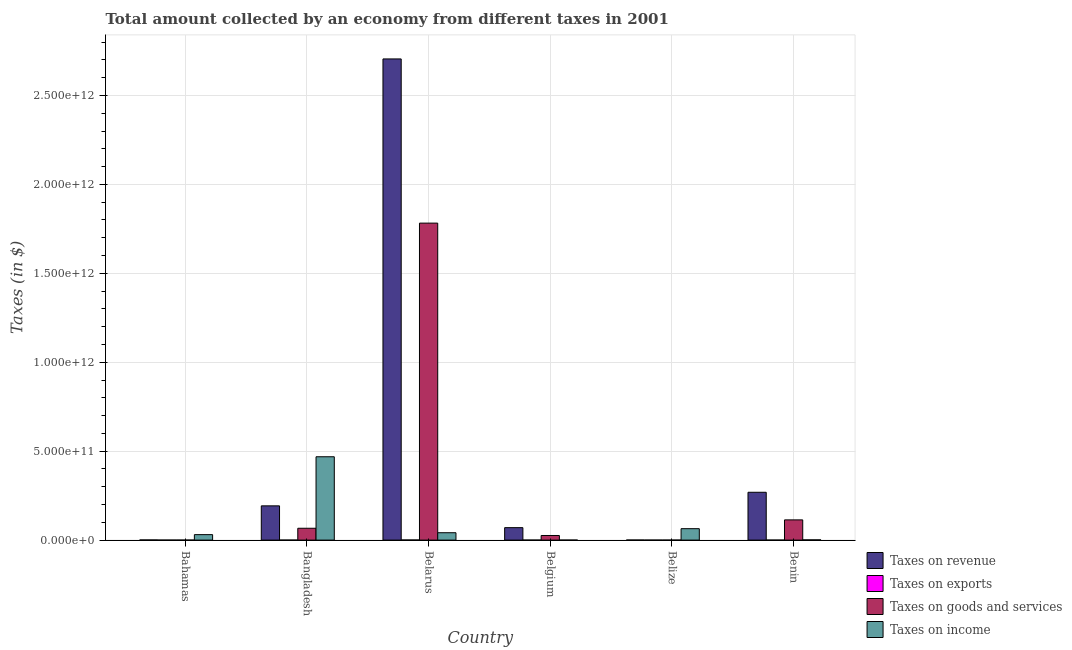How many different coloured bars are there?
Offer a very short reply. 4. Are the number of bars per tick equal to the number of legend labels?
Provide a short and direct response. Yes. What is the label of the 5th group of bars from the left?
Make the answer very short. Belize. What is the amount collected as tax on income in Belarus?
Provide a short and direct response. 4.14e+1. Across all countries, what is the maximum amount collected as tax on revenue?
Offer a terse response. 2.71e+12. Across all countries, what is the minimum amount collected as tax on revenue?
Offer a very short reply. 3.26e+08. In which country was the amount collected as tax on goods minimum?
Your response must be concise. Bahamas. What is the total amount collected as tax on income in the graph?
Ensure brevity in your answer.  6.06e+11. What is the difference between the amount collected as tax on revenue in Belgium and that in Benin?
Ensure brevity in your answer.  -1.99e+11. What is the difference between the amount collected as tax on income in Belize and the amount collected as tax on revenue in Belgium?
Provide a short and direct response. -5.74e+09. What is the average amount collected as tax on exports per country?
Give a very brief answer. 1.33e+08. What is the difference between the amount collected as tax on income and amount collected as tax on revenue in Bahamas?
Your answer should be compact. 2.99e+1. What is the ratio of the amount collected as tax on exports in Bangladesh to that in Belgium?
Your answer should be very brief. 0. What is the difference between the highest and the second highest amount collected as tax on goods?
Your answer should be very brief. 1.67e+12. What is the difference between the highest and the lowest amount collected as tax on goods?
Offer a very short reply. 1.78e+12. In how many countries, is the amount collected as tax on goods greater than the average amount collected as tax on goods taken over all countries?
Keep it short and to the point. 1. Is the sum of the amount collected as tax on income in Bahamas and Benin greater than the maximum amount collected as tax on goods across all countries?
Offer a very short reply. No. Is it the case that in every country, the sum of the amount collected as tax on revenue and amount collected as tax on exports is greater than the sum of amount collected as tax on goods and amount collected as tax on income?
Provide a short and direct response. No. What does the 2nd bar from the left in Benin represents?
Keep it short and to the point. Taxes on exports. What does the 3rd bar from the right in Bangladesh represents?
Your response must be concise. Taxes on exports. Is it the case that in every country, the sum of the amount collected as tax on revenue and amount collected as tax on exports is greater than the amount collected as tax on goods?
Give a very brief answer. Yes. Are all the bars in the graph horizontal?
Your answer should be very brief. No. How many countries are there in the graph?
Provide a succinct answer. 6. What is the difference between two consecutive major ticks on the Y-axis?
Give a very brief answer. 5.00e+11. Does the graph contain any zero values?
Your answer should be compact. No. Does the graph contain grids?
Keep it short and to the point. Yes. Where does the legend appear in the graph?
Provide a succinct answer. Bottom right. How are the legend labels stacked?
Provide a succinct answer. Vertical. What is the title of the graph?
Make the answer very short. Total amount collected by an economy from different taxes in 2001. What is the label or title of the X-axis?
Make the answer very short. Country. What is the label or title of the Y-axis?
Keep it short and to the point. Taxes (in $). What is the Taxes (in $) of Taxes on revenue in Bahamas?
Offer a very short reply. 8.20e+08. What is the Taxes (in $) of Taxes on exports in Bahamas?
Give a very brief answer. 1.32e+07. What is the Taxes (in $) of Taxes on goods and services in Bahamas?
Offer a very short reply. 5.29e+07. What is the Taxes (in $) of Taxes on income in Bahamas?
Ensure brevity in your answer.  3.07e+1. What is the Taxes (in $) of Taxes on revenue in Bangladesh?
Keep it short and to the point. 1.93e+11. What is the Taxes (in $) in Taxes on exports in Bangladesh?
Give a very brief answer. 1.46e+04. What is the Taxes (in $) of Taxes on goods and services in Bangladesh?
Offer a terse response. 6.66e+1. What is the Taxes (in $) of Taxes on income in Bangladesh?
Your answer should be compact. 4.69e+11. What is the Taxes (in $) of Taxes on revenue in Belarus?
Offer a terse response. 2.71e+12. What is the Taxes (in $) in Taxes on exports in Belarus?
Give a very brief answer. 6.54e+08. What is the Taxes (in $) of Taxes on goods and services in Belarus?
Give a very brief answer. 1.78e+12. What is the Taxes (in $) of Taxes on income in Belarus?
Your answer should be compact. 4.14e+1. What is the Taxes (in $) in Taxes on revenue in Belgium?
Provide a short and direct response. 7.00e+1. What is the Taxes (in $) of Taxes on exports in Belgium?
Your answer should be very brief. 1.03e+08. What is the Taxes (in $) of Taxes on goods and services in Belgium?
Your answer should be compact. 2.59e+1. What is the Taxes (in $) of Taxes on income in Belgium?
Make the answer very short. 7.70e+07. What is the Taxes (in $) in Taxes on revenue in Belize?
Provide a short and direct response. 3.26e+08. What is the Taxes (in $) of Taxes on exports in Belize?
Keep it short and to the point. 3.00e+07. What is the Taxes (in $) of Taxes on goods and services in Belize?
Keep it short and to the point. 1.08e+08. What is the Taxes (in $) of Taxes on income in Belize?
Offer a terse response. 6.43e+1. What is the Taxes (in $) in Taxes on revenue in Benin?
Give a very brief answer. 2.69e+11. What is the Taxes (in $) in Taxes on goods and services in Benin?
Keep it short and to the point. 1.14e+11. What is the Taxes (in $) in Taxes on income in Benin?
Ensure brevity in your answer.  1.19e+09. Across all countries, what is the maximum Taxes (in $) in Taxes on revenue?
Offer a very short reply. 2.71e+12. Across all countries, what is the maximum Taxes (in $) of Taxes on exports?
Your answer should be very brief. 6.54e+08. Across all countries, what is the maximum Taxes (in $) of Taxes on goods and services?
Provide a succinct answer. 1.78e+12. Across all countries, what is the maximum Taxes (in $) of Taxes on income?
Your answer should be compact. 4.69e+11. Across all countries, what is the minimum Taxes (in $) in Taxes on revenue?
Your answer should be very brief. 3.26e+08. Across all countries, what is the minimum Taxes (in $) of Taxes on exports?
Your answer should be compact. 1.46e+04. Across all countries, what is the minimum Taxes (in $) of Taxes on goods and services?
Offer a very short reply. 5.29e+07. Across all countries, what is the minimum Taxes (in $) in Taxes on income?
Ensure brevity in your answer.  7.70e+07. What is the total Taxes (in $) of Taxes on revenue in the graph?
Give a very brief answer. 3.24e+12. What is the total Taxes (in $) in Taxes on exports in the graph?
Keep it short and to the point. 8.01e+08. What is the total Taxes (in $) of Taxes on goods and services in the graph?
Ensure brevity in your answer.  1.99e+12. What is the total Taxes (in $) of Taxes on income in the graph?
Your answer should be compact. 6.06e+11. What is the difference between the Taxes (in $) in Taxes on revenue in Bahamas and that in Bangladesh?
Offer a terse response. -1.92e+11. What is the difference between the Taxes (in $) of Taxes on exports in Bahamas and that in Bangladesh?
Your response must be concise. 1.32e+07. What is the difference between the Taxes (in $) of Taxes on goods and services in Bahamas and that in Bangladesh?
Provide a succinct answer. -6.65e+1. What is the difference between the Taxes (in $) of Taxes on income in Bahamas and that in Bangladesh?
Keep it short and to the point. -4.38e+11. What is the difference between the Taxes (in $) of Taxes on revenue in Bahamas and that in Belarus?
Your answer should be very brief. -2.70e+12. What is the difference between the Taxes (in $) of Taxes on exports in Bahamas and that in Belarus?
Make the answer very short. -6.40e+08. What is the difference between the Taxes (in $) in Taxes on goods and services in Bahamas and that in Belarus?
Provide a succinct answer. -1.78e+12. What is the difference between the Taxes (in $) of Taxes on income in Bahamas and that in Belarus?
Your answer should be compact. -1.07e+1. What is the difference between the Taxes (in $) in Taxes on revenue in Bahamas and that in Belgium?
Make the answer very short. -6.92e+1. What is the difference between the Taxes (in $) in Taxes on exports in Bahamas and that in Belgium?
Make the answer very short. -8.98e+07. What is the difference between the Taxes (in $) in Taxes on goods and services in Bahamas and that in Belgium?
Give a very brief answer. -2.59e+1. What is the difference between the Taxes (in $) in Taxes on income in Bahamas and that in Belgium?
Provide a short and direct response. 3.07e+1. What is the difference between the Taxes (in $) in Taxes on revenue in Bahamas and that in Belize?
Offer a very short reply. 4.94e+08. What is the difference between the Taxes (in $) of Taxes on exports in Bahamas and that in Belize?
Give a very brief answer. -1.68e+07. What is the difference between the Taxes (in $) in Taxes on goods and services in Bahamas and that in Belize?
Provide a succinct answer. -5.50e+07. What is the difference between the Taxes (in $) of Taxes on income in Bahamas and that in Belize?
Provide a short and direct response. -3.35e+1. What is the difference between the Taxes (in $) in Taxes on revenue in Bahamas and that in Benin?
Ensure brevity in your answer.  -2.68e+11. What is the difference between the Taxes (in $) of Taxes on exports in Bahamas and that in Benin?
Provide a short and direct response. 1.23e+07. What is the difference between the Taxes (in $) in Taxes on goods and services in Bahamas and that in Benin?
Offer a very short reply. -1.14e+11. What is the difference between the Taxes (in $) of Taxes on income in Bahamas and that in Benin?
Ensure brevity in your answer.  2.96e+1. What is the difference between the Taxes (in $) of Taxes on revenue in Bangladesh and that in Belarus?
Your answer should be very brief. -2.51e+12. What is the difference between the Taxes (in $) of Taxes on exports in Bangladesh and that in Belarus?
Your answer should be compact. -6.54e+08. What is the difference between the Taxes (in $) in Taxes on goods and services in Bangladesh and that in Belarus?
Your answer should be very brief. -1.72e+12. What is the difference between the Taxes (in $) in Taxes on income in Bangladesh and that in Belarus?
Offer a very short reply. 4.27e+11. What is the difference between the Taxes (in $) in Taxes on revenue in Bangladesh and that in Belgium?
Keep it short and to the point. 1.23e+11. What is the difference between the Taxes (in $) of Taxes on exports in Bangladesh and that in Belgium?
Offer a very short reply. -1.03e+08. What is the difference between the Taxes (in $) in Taxes on goods and services in Bangladesh and that in Belgium?
Your response must be concise. 4.06e+1. What is the difference between the Taxes (in $) in Taxes on income in Bangladesh and that in Belgium?
Give a very brief answer. 4.69e+11. What is the difference between the Taxes (in $) of Taxes on revenue in Bangladesh and that in Belize?
Make the answer very short. 1.92e+11. What is the difference between the Taxes (in $) of Taxes on exports in Bangladesh and that in Belize?
Your answer should be compact. -3.00e+07. What is the difference between the Taxes (in $) of Taxes on goods and services in Bangladesh and that in Belize?
Offer a terse response. 6.65e+1. What is the difference between the Taxes (in $) in Taxes on income in Bangladesh and that in Belize?
Make the answer very short. 4.04e+11. What is the difference between the Taxes (in $) in Taxes on revenue in Bangladesh and that in Benin?
Your answer should be very brief. -7.63e+1. What is the difference between the Taxes (in $) of Taxes on exports in Bangladesh and that in Benin?
Keep it short and to the point. -8.85e+05. What is the difference between the Taxes (in $) of Taxes on goods and services in Bangladesh and that in Benin?
Offer a very short reply. -4.72e+1. What is the difference between the Taxes (in $) of Taxes on income in Bangladesh and that in Benin?
Keep it short and to the point. 4.67e+11. What is the difference between the Taxes (in $) of Taxes on revenue in Belarus and that in Belgium?
Provide a short and direct response. 2.64e+12. What is the difference between the Taxes (in $) in Taxes on exports in Belarus and that in Belgium?
Your answer should be compact. 5.51e+08. What is the difference between the Taxes (in $) in Taxes on goods and services in Belarus and that in Belgium?
Make the answer very short. 1.76e+12. What is the difference between the Taxes (in $) in Taxes on income in Belarus and that in Belgium?
Provide a succinct answer. 4.14e+1. What is the difference between the Taxes (in $) of Taxes on revenue in Belarus and that in Belize?
Offer a very short reply. 2.71e+12. What is the difference between the Taxes (in $) in Taxes on exports in Belarus and that in Belize?
Your answer should be compact. 6.24e+08. What is the difference between the Taxes (in $) in Taxes on goods and services in Belarus and that in Belize?
Your answer should be compact. 1.78e+12. What is the difference between the Taxes (in $) of Taxes on income in Belarus and that in Belize?
Offer a very short reply. -2.28e+1. What is the difference between the Taxes (in $) of Taxes on revenue in Belarus and that in Benin?
Provide a short and direct response. 2.44e+12. What is the difference between the Taxes (in $) of Taxes on exports in Belarus and that in Benin?
Your answer should be very brief. 6.53e+08. What is the difference between the Taxes (in $) in Taxes on goods and services in Belarus and that in Benin?
Provide a succinct answer. 1.67e+12. What is the difference between the Taxes (in $) of Taxes on income in Belarus and that in Benin?
Your response must be concise. 4.02e+1. What is the difference between the Taxes (in $) of Taxes on revenue in Belgium and that in Belize?
Make the answer very short. 6.97e+1. What is the difference between the Taxes (in $) in Taxes on exports in Belgium and that in Belize?
Offer a terse response. 7.30e+07. What is the difference between the Taxes (in $) of Taxes on goods and services in Belgium and that in Belize?
Offer a very short reply. 2.58e+1. What is the difference between the Taxes (in $) of Taxes on income in Belgium and that in Belize?
Provide a short and direct response. -6.42e+1. What is the difference between the Taxes (in $) of Taxes on revenue in Belgium and that in Benin?
Make the answer very short. -1.99e+11. What is the difference between the Taxes (in $) of Taxes on exports in Belgium and that in Benin?
Provide a short and direct response. 1.02e+08. What is the difference between the Taxes (in $) of Taxes on goods and services in Belgium and that in Benin?
Your answer should be very brief. -8.78e+1. What is the difference between the Taxes (in $) of Taxes on income in Belgium and that in Benin?
Ensure brevity in your answer.  -1.11e+09. What is the difference between the Taxes (in $) in Taxes on revenue in Belize and that in Benin?
Offer a terse response. -2.69e+11. What is the difference between the Taxes (in $) in Taxes on exports in Belize and that in Benin?
Your answer should be very brief. 2.91e+07. What is the difference between the Taxes (in $) of Taxes on goods and services in Belize and that in Benin?
Ensure brevity in your answer.  -1.14e+11. What is the difference between the Taxes (in $) of Taxes on income in Belize and that in Benin?
Provide a succinct answer. 6.31e+1. What is the difference between the Taxes (in $) in Taxes on revenue in Bahamas and the Taxes (in $) in Taxes on exports in Bangladesh?
Offer a very short reply. 8.20e+08. What is the difference between the Taxes (in $) of Taxes on revenue in Bahamas and the Taxes (in $) of Taxes on goods and services in Bangladesh?
Give a very brief answer. -6.57e+1. What is the difference between the Taxes (in $) in Taxes on revenue in Bahamas and the Taxes (in $) in Taxes on income in Bangladesh?
Provide a succinct answer. -4.68e+11. What is the difference between the Taxes (in $) in Taxes on exports in Bahamas and the Taxes (in $) in Taxes on goods and services in Bangladesh?
Your answer should be compact. -6.66e+1. What is the difference between the Taxes (in $) in Taxes on exports in Bahamas and the Taxes (in $) in Taxes on income in Bangladesh?
Offer a very short reply. -4.69e+11. What is the difference between the Taxes (in $) of Taxes on goods and services in Bahamas and the Taxes (in $) of Taxes on income in Bangladesh?
Provide a short and direct response. -4.69e+11. What is the difference between the Taxes (in $) in Taxes on revenue in Bahamas and the Taxes (in $) in Taxes on exports in Belarus?
Provide a succinct answer. 1.67e+08. What is the difference between the Taxes (in $) of Taxes on revenue in Bahamas and the Taxes (in $) of Taxes on goods and services in Belarus?
Provide a short and direct response. -1.78e+12. What is the difference between the Taxes (in $) in Taxes on revenue in Bahamas and the Taxes (in $) in Taxes on income in Belarus?
Your answer should be compact. -4.06e+1. What is the difference between the Taxes (in $) in Taxes on exports in Bahamas and the Taxes (in $) in Taxes on goods and services in Belarus?
Make the answer very short. -1.78e+12. What is the difference between the Taxes (in $) of Taxes on exports in Bahamas and the Taxes (in $) of Taxes on income in Belarus?
Provide a short and direct response. -4.14e+1. What is the difference between the Taxes (in $) in Taxes on goods and services in Bahamas and the Taxes (in $) in Taxes on income in Belarus?
Provide a succinct answer. -4.14e+1. What is the difference between the Taxes (in $) in Taxes on revenue in Bahamas and the Taxes (in $) in Taxes on exports in Belgium?
Ensure brevity in your answer.  7.17e+08. What is the difference between the Taxes (in $) of Taxes on revenue in Bahamas and the Taxes (in $) of Taxes on goods and services in Belgium?
Offer a terse response. -2.51e+1. What is the difference between the Taxes (in $) of Taxes on revenue in Bahamas and the Taxes (in $) of Taxes on income in Belgium?
Keep it short and to the point. 7.43e+08. What is the difference between the Taxes (in $) in Taxes on exports in Bahamas and the Taxes (in $) in Taxes on goods and services in Belgium?
Keep it short and to the point. -2.59e+1. What is the difference between the Taxes (in $) in Taxes on exports in Bahamas and the Taxes (in $) in Taxes on income in Belgium?
Give a very brief answer. -6.38e+07. What is the difference between the Taxes (in $) of Taxes on goods and services in Bahamas and the Taxes (in $) of Taxes on income in Belgium?
Ensure brevity in your answer.  -2.41e+07. What is the difference between the Taxes (in $) of Taxes on revenue in Bahamas and the Taxes (in $) of Taxes on exports in Belize?
Give a very brief answer. 7.90e+08. What is the difference between the Taxes (in $) of Taxes on revenue in Bahamas and the Taxes (in $) of Taxes on goods and services in Belize?
Your answer should be very brief. 7.12e+08. What is the difference between the Taxes (in $) of Taxes on revenue in Bahamas and the Taxes (in $) of Taxes on income in Belize?
Your answer should be compact. -6.34e+1. What is the difference between the Taxes (in $) in Taxes on exports in Bahamas and the Taxes (in $) in Taxes on goods and services in Belize?
Ensure brevity in your answer.  -9.47e+07. What is the difference between the Taxes (in $) of Taxes on exports in Bahamas and the Taxes (in $) of Taxes on income in Belize?
Provide a short and direct response. -6.42e+1. What is the difference between the Taxes (in $) in Taxes on goods and services in Bahamas and the Taxes (in $) in Taxes on income in Belize?
Your response must be concise. -6.42e+1. What is the difference between the Taxes (in $) in Taxes on revenue in Bahamas and the Taxes (in $) in Taxes on exports in Benin?
Your response must be concise. 8.19e+08. What is the difference between the Taxes (in $) of Taxes on revenue in Bahamas and the Taxes (in $) of Taxes on goods and services in Benin?
Ensure brevity in your answer.  -1.13e+11. What is the difference between the Taxes (in $) of Taxes on revenue in Bahamas and the Taxes (in $) of Taxes on income in Benin?
Provide a short and direct response. -3.72e+08. What is the difference between the Taxes (in $) of Taxes on exports in Bahamas and the Taxes (in $) of Taxes on goods and services in Benin?
Your answer should be compact. -1.14e+11. What is the difference between the Taxes (in $) in Taxes on exports in Bahamas and the Taxes (in $) in Taxes on income in Benin?
Ensure brevity in your answer.  -1.18e+09. What is the difference between the Taxes (in $) of Taxes on goods and services in Bahamas and the Taxes (in $) of Taxes on income in Benin?
Your answer should be very brief. -1.14e+09. What is the difference between the Taxes (in $) of Taxes on revenue in Bangladesh and the Taxes (in $) of Taxes on exports in Belarus?
Ensure brevity in your answer.  1.92e+11. What is the difference between the Taxes (in $) of Taxes on revenue in Bangladesh and the Taxes (in $) of Taxes on goods and services in Belarus?
Provide a short and direct response. -1.59e+12. What is the difference between the Taxes (in $) of Taxes on revenue in Bangladesh and the Taxes (in $) of Taxes on income in Belarus?
Ensure brevity in your answer.  1.51e+11. What is the difference between the Taxes (in $) in Taxes on exports in Bangladesh and the Taxes (in $) in Taxes on goods and services in Belarus?
Keep it short and to the point. -1.78e+12. What is the difference between the Taxes (in $) in Taxes on exports in Bangladesh and the Taxes (in $) in Taxes on income in Belarus?
Keep it short and to the point. -4.14e+1. What is the difference between the Taxes (in $) of Taxes on goods and services in Bangladesh and the Taxes (in $) of Taxes on income in Belarus?
Your answer should be very brief. 2.51e+1. What is the difference between the Taxes (in $) in Taxes on revenue in Bangladesh and the Taxes (in $) in Taxes on exports in Belgium?
Offer a very short reply. 1.93e+11. What is the difference between the Taxes (in $) in Taxes on revenue in Bangladesh and the Taxes (in $) in Taxes on goods and services in Belgium?
Offer a terse response. 1.67e+11. What is the difference between the Taxes (in $) in Taxes on revenue in Bangladesh and the Taxes (in $) in Taxes on income in Belgium?
Your answer should be very brief. 1.93e+11. What is the difference between the Taxes (in $) in Taxes on exports in Bangladesh and the Taxes (in $) in Taxes on goods and services in Belgium?
Offer a terse response. -2.59e+1. What is the difference between the Taxes (in $) in Taxes on exports in Bangladesh and the Taxes (in $) in Taxes on income in Belgium?
Your response must be concise. -7.70e+07. What is the difference between the Taxes (in $) of Taxes on goods and services in Bangladesh and the Taxes (in $) of Taxes on income in Belgium?
Your response must be concise. 6.65e+1. What is the difference between the Taxes (in $) of Taxes on revenue in Bangladesh and the Taxes (in $) of Taxes on exports in Belize?
Your answer should be very brief. 1.93e+11. What is the difference between the Taxes (in $) in Taxes on revenue in Bangladesh and the Taxes (in $) in Taxes on goods and services in Belize?
Your answer should be very brief. 1.92e+11. What is the difference between the Taxes (in $) of Taxes on revenue in Bangladesh and the Taxes (in $) of Taxes on income in Belize?
Your answer should be very brief. 1.28e+11. What is the difference between the Taxes (in $) in Taxes on exports in Bangladesh and the Taxes (in $) in Taxes on goods and services in Belize?
Your answer should be very brief. -1.08e+08. What is the difference between the Taxes (in $) in Taxes on exports in Bangladesh and the Taxes (in $) in Taxes on income in Belize?
Your response must be concise. -6.43e+1. What is the difference between the Taxes (in $) of Taxes on goods and services in Bangladesh and the Taxes (in $) of Taxes on income in Belize?
Keep it short and to the point. 2.31e+09. What is the difference between the Taxes (in $) in Taxes on revenue in Bangladesh and the Taxes (in $) in Taxes on exports in Benin?
Offer a very short reply. 1.93e+11. What is the difference between the Taxes (in $) in Taxes on revenue in Bangladesh and the Taxes (in $) in Taxes on goods and services in Benin?
Provide a short and direct response. 7.89e+1. What is the difference between the Taxes (in $) of Taxes on revenue in Bangladesh and the Taxes (in $) of Taxes on income in Benin?
Offer a terse response. 1.91e+11. What is the difference between the Taxes (in $) in Taxes on exports in Bangladesh and the Taxes (in $) in Taxes on goods and services in Benin?
Make the answer very short. -1.14e+11. What is the difference between the Taxes (in $) of Taxes on exports in Bangladesh and the Taxes (in $) of Taxes on income in Benin?
Offer a very short reply. -1.19e+09. What is the difference between the Taxes (in $) of Taxes on goods and services in Bangladesh and the Taxes (in $) of Taxes on income in Benin?
Your answer should be compact. 6.54e+1. What is the difference between the Taxes (in $) of Taxes on revenue in Belarus and the Taxes (in $) of Taxes on exports in Belgium?
Offer a very short reply. 2.71e+12. What is the difference between the Taxes (in $) of Taxes on revenue in Belarus and the Taxes (in $) of Taxes on goods and services in Belgium?
Make the answer very short. 2.68e+12. What is the difference between the Taxes (in $) of Taxes on revenue in Belarus and the Taxes (in $) of Taxes on income in Belgium?
Provide a short and direct response. 2.71e+12. What is the difference between the Taxes (in $) of Taxes on exports in Belarus and the Taxes (in $) of Taxes on goods and services in Belgium?
Offer a very short reply. -2.53e+1. What is the difference between the Taxes (in $) of Taxes on exports in Belarus and the Taxes (in $) of Taxes on income in Belgium?
Give a very brief answer. 5.77e+08. What is the difference between the Taxes (in $) in Taxes on goods and services in Belarus and the Taxes (in $) in Taxes on income in Belgium?
Give a very brief answer. 1.78e+12. What is the difference between the Taxes (in $) in Taxes on revenue in Belarus and the Taxes (in $) in Taxes on exports in Belize?
Make the answer very short. 2.71e+12. What is the difference between the Taxes (in $) of Taxes on revenue in Belarus and the Taxes (in $) of Taxes on goods and services in Belize?
Your response must be concise. 2.71e+12. What is the difference between the Taxes (in $) of Taxes on revenue in Belarus and the Taxes (in $) of Taxes on income in Belize?
Give a very brief answer. 2.64e+12. What is the difference between the Taxes (in $) in Taxes on exports in Belarus and the Taxes (in $) in Taxes on goods and services in Belize?
Provide a short and direct response. 5.46e+08. What is the difference between the Taxes (in $) of Taxes on exports in Belarus and the Taxes (in $) of Taxes on income in Belize?
Give a very brief answer. -6.36e+1. What is the difference between the Taxes (in $) of Taxes on goods and services in Belarus and the Taxes (in $) of Taxes on income in Belize?
Your answer should be compact. 1.72e+12. What is the difference between the Taxes (in $) of Taxes on revenue in Belarus and the Taxes (in $) of Taxes on exports in Benin?
Offer a very short reply. 2.71e+12. What is the difference between the Taxes (in $) of Taxes on revenue in Belarus and the Taxes (in $) of Taxes on goods and services in Benin?
Ensure brevity in your answer.  2.59e+12. What is the difference between the Taxes (in $) of Taxes on revenue in Belarus and the Taxes (in $) of Taxes on income in Benin?
Ensure brevity in your answer.  2.70e+12. What is the difference between the Taxes (in $) of Taxes on exports in Belarus and the Taxes (in $) of Taxes on goods and services in Benin?
Provide a short and direct response. -1.13e+11. What is the difference between the Taxes (in $) in Taxes on exports in Belarus and the Taxes (in $) in Taxes on income in Benin?
Make the answer very short. -5.38e+08. What is the difference between the Taxes (in $) in Taxes on goods and services in Belarus and the Taxes (in $) in Taxes on income in Benin?
Give a very brief answer. 1.78e+12. What is the difference between the Taxes (in $) in Taxes on revenue in Belgium and the Taxes (in $) in Taxes on exports in Belize?
Your response must be concise. 7.00e+1. What is the difference between the Taxes (in $) of Taxes on revenue in Belgium and the Taxes (in $) of Taxes on goods and services in Belize?
Keep it short and to the point. 6.99e+1. What is the difference between the Taxes (in $) in Taxes on revenue in Belgium and the Taxes (in $) in Taxes on income in Belize?
Make the answer very short. 5.74e+09. What is the difference between the Taxes (in $) in Taxes on exports in Belgium and the Taxes (in $) in Taxes on goods and services in Belize?
Your answer should be very brief. -4.95e+06. What is the difference between the Taxes (in $) of Taxes on exports in Belgium and the Taxes (in $) of Taxes on income in Belize?
Your answer should be very brief. -6.42e+1. What is the difference between the Taxes (in $) of Taxes on goods and services in Belgium and the Taxes (in $) of Taxes on income in Belize?
Offer a terse response. -3.83e+1. What is the difference between the Taxes (in $) in Taxes on revenue in Belgium and the Taxes (in $) in Taxes on exports in Benin?
Offer a very short reply. 7.00e+1. What is the difference between the Taxes (in $) of Taxes on revenue in Belgium and the Taxes (in $) of Taxes on goods and services in Benin?
Provide a short and direct response. -4.37e+1. What is the difference between the Taxes (in $) of Taxes on revenue in Belgium and the Taxes (in $) of Taxes on income in Benin?
Your answer should be very brief. 6.88e+1. What is the difference between the Taxes (in $) in Taxes on exports in Belgium and the Taxes (in $) in Taxes on goods and services in Benin?
Provide a short and direct response. -1.14e+11. What is the difference between the Taxes (in $) in Taxes on exports in Belgium and the Taxes (in $) in Taxes on income in Benin?
Offer a very short reply. -1.09e+09. What is the difference between the Taxes (in $) in Taxes on goods and services in Belgium and the Taxes (in $) in Taxes on income in Benin?
Make the answer very short. 2.47e+1. What is the difference between the Taxes (in $) of Taxes on revenue in Belize and the Taxes (in $) of Taxes on exports in Benin?
Provide a succinct answer. 3.25e+08. What is the difference between the Taxes (in $) in Taxes on revenue in Belize and the Taxes (in $) in Taxes on goods and services in Benin?
Make the answer very short. -1.13e+11. What is the difference between the Taxes (in $) of Taxes on revenue in Belize and the Taxes (in $) of Taxes on income in Benin?
Provide a short and direct response. -8.66e+08. What is the difference between the Taxes (in $) of Taxes on exports in Belize and the Taxes (in $) of Taxes on goods and services in Benin?
Your answer should be compact. -1.14e+11. What is the difference between the Taxes (in $) of Taxes on exports in Belize and the Taxes (in $) of Taxes on income in Benin?
Make the answer very short. -1.16e+09. What is the difference between the Taxes (in $) of Taxes on goods and services in Belize and the Taxes (in $) of Taxes on income in Benin?
Provide a succinct answer. -1.08e+09. What is the average Taxes (in $) in Taxes on revenue per country?
Provide a short and direct response. 5.40e+11. What is the average Taxes (in $) of Taxes on exports per country?
Give a very brief answer. 1.33e+08. What is the average Taxes (in $) of Taxes on goods and services per country?
Offer a terse response. 3.31e+11. What is the average Taxes (in $) of Taxes on income per country?
Offer a terse response. 1.01e+11. What is the difference between the Taxes (in $) of Taxes on revenue and Taxes (in $) of Taxes on exports in Bahamas?
Your response must be concise. 8.07e+08. What is the difference between the Taxes (in $) in Taxes on revenue and Taxes (in $) in Taxes on goods and services in Bahamas?
Your answer should be compact. 7.67e+08. What is the difference between the Taxes (in $) in Taxes on revenue and Taxes (in $) in Taxes on income in Bahamas?
Keep it short and to the point. -2.99e+1. What is the difference between the Taxes (in $) of Taxes on exports and Taxes (in $) of Taxes on goods and services in Bahamas?
Provide a short and direct response. -3.97e+07. What is the difference between the Taxes (in $) of Taxes on exports and Taxes (in $) of Taxes on income in Bahamas?
Your response must be concise. -3.07e+1. What is the difference between the Taxes (in $) of Taxes on goods and services and Taxes (in $) of Taxes on income in Bahamas?
Keep it short and to the point. -3.07e+1. What is the difference between the Taxes (in $) in Taxes on revenue and Taxes (in $) in Taxes on exports in Bangladesh?
Give a very brief answer. 1.93e+11. What is the difference between the Taxes (in $) in Taxes on revenue and Taxes (in $) in Taxes on goods and services in Bangladesh?
Ensure brevity in your answer.  1.26e+11. What is the difference between the Taxes (in $) in Taxes on revenue and Taxes (in $) in Taxes on income in Bangladesh?
Your answer should be very brief. -2.76e+11. What is the difference between the Taxes (in $) in Taxes on exports and Taxes (in $) in Taxes on goods and services in Bangladesh?
Your answer should be compact. -6.66e+1. What is the difference between the Taxes (in $) of Taxes on exports and Taxes (in $) of Taxes on income in Bangladesh?
Ensure brevity in your answer.  -4.69e+11. What is the difference between the Taxes (in $) in Taxes on goods and services and Taxes (in $) in Taxes on income in Bangladesh?
Offer a very short reply. -4.02e+11. What is the difference between the Taxes (in $) in Taxes on revenue and Taxes (in $) in Taxes on exports in Belarus?
Keep it short and to the point. 2.70e+12. What is the difference between the Taxes (in $) of Taxes on revenue and Taxes (in $) of Taxes on goods and services in Belarus?
Give a very brief answer. 9.23e+11. What is the difference between the Taxes (in $) of Taxes on revenue and Taxes (in $) of Taxes on income in Belarus?
Give a very brief answer. 2.66e+12. What is the difference between the Taxes (in $) in Taxes on exports and Taxes (in $) in Taxes on goods and services in Belarus?
Give a very brief answer. -1.78e+12. What is the difference between the Taxes (in $) of Taxes on exports and Taxes (in $) of Taxes on income in Belarus?
Ensure brevity in your answer.  -4.08e+1. What is the difference between the Taxes (in $) of Taxes on goods and services and Taxes (in $) of Taxes on income in Belarus?
Give a very brief answer. 1.74e+12. What is the difference between the Taxes (in $) in Taxes on revenue and Taxes (in $) in Taxes on exports in Belgium?
Provide a succinct answer. 6.99e+1. What is the difference between the Taxes (in $) of Taxes on revenue and Taxes (in $) of Taxes on goods and services in Belgium?
Provide a short and direct response. 4.41e+1. What is the difference between the Taxes (in $) of Taxes on revenue and Taxes (in $) of Taxes on income in Belgium?
Give a very brief answer. 6.99e+1. What is the difference between the Taxes (in $) of Taxes on exports and Taxes (in $) of Taxes on goods and services in Belgium?
Keep it short and to the point. -2.58e+1. What is the difference between the Taxes (in $) of Taxes on exports and Taxes (in $) of Taxes on income in Belgium?
Offer a terse response. 2.60e+07. What is the difference between the Taxes (in $) of Taxes on goods and services and Taxes (in $) of Taxes on income in Belgium?
Provide a short and direct response. 2.59e+1. What is the difference between the Taxes (in $) in Taxes on revenue and Taxes (in $) in Taxes on exports in Belize?
Your answer should be compact. 2.96e+08. What is the difference between the Taxes (in $) of Taxes on revenue and Taxes (in $) of Taxes on goods and services in Belize?
Offer a terse response. 2.18e+08. What is the difference between the Taxes (in $) in Taxes on revenue and Taxes (in $) in Taxes on income in Belize?
Make the answer very short. -6.39e+1. What is the difference between the Taxes (in $) of Taxes on exports and Taxes (in $) of Taxes on goods and services in Belize?
Offer a very short reply. -7.80e+07. What is the difference between the Taxes (in $) in Taxes on exports and Taxes (in $) in Taxes on income in Belize?
Provide a succinct answer. -6.42e+1. What is the difference between the Taxes (in $) of Taxes on goods and services and Taxes (in $) of Taxes on income in Belize?
Your response must be concise. -6.42e+1. What is the difference between the Taxes (in $) in Taxes on revenue and Taxes (in $) in Taxes on exports in Benin?
Provide a succinct answer. 2.69e+11. What is the difference between the Taxes (in $) in Taxes on revenue and Taxes (in $) in Taxes on goods and services in Benin?
Keep it short and to the point. 1.55e+11. What is the difference between the Taxes (in $) of Taxes on revenue and Taxes (in $) of Taxes on income in Benin?
Your response must be concise. 2.68e+11. What is the difference between the Taxes (in $) in Taxes on exports and Taxes (in $) in Taxes on goods and services in Benin?
Your response must be concise. -1.14e+11. What is the difference between the Taxes (in $) in Taxes on exports and Taxes (in $) in Taxes on income in Benin?
Make the answer very short. -1.19e+09. What is the difference between the Taxes (in $) in Taxes on goods and services and Taxes (in $) in Taxes on income in Benin?
Your answer should be very brief. 1.13e+11. What is the ratio of the Taxes (in $) in Taxes on revenue in Bahamas to that in Bangladesh?
Provide a succinct answer. 0. What is the ratio of the Taxes (in $) of Taxes on exports in Bahamas to that in Bangladesh?
Offer a very short reply. 904.11. What is the ratio of the Taxes (in $) of Taxes on goods and services in Bahamas to that in Bangladesh?
Ensure brevity in your answer.  0. What is the ratio of the Taxes (in $) in Taxes on income in Bahamas to that in Bangladesh?
Ensure brevity in your answer.  0.07. What is the ratio of the Taxes (in $) in Taxes on revenue in Bahamas to that in Belarus?
Ensure brevity in your answer.  0. What is the ratio of the Taxes (in $) in Taxes on exports in Bahamas to that in Belarus?
Make the answer very short. 0.02. What is the ratio of the Taxes (in $) of Taxes on income in Bahamas to that in Belarus?
Provide a short and direct response. 0.74. What is the ratio of the Taxes (in $) in Taxes on revenue in Bahamas to that in Belgium?
Offer a very short reply. 0.01. What is the ratio of the Taxes (in $) of Taxes on exports in Bahamas to that in Belgium?
Give a very brief answer. 0.13. What is the ratio of the Taxes (in $) of Taxes on goods and services in Bahamas to that in Belgium?
Give a very brief answer. 0. What is the ratio of the Taxes (in $) in Taxes on income in Bahamas to that in Belgium?
Offer a terse response. 399.41. What is the ratio of the Taxes (in $) of Taxes on revenue in Bahamas to that in Belize?
Offer a very short reply. 2.51. What is the ratio of the Taxes (in $) of Taxes on exports in Bahamas to that in Belize?
Ensure brevity in your answer.  0.44. What is the ratio of the Taxes (in $) in Taxes on goods and services in Bahamas to that in Belize?
Your answer should be compact. 0.49. What is the ratio of the Taxes (in $) in Taxes on income in Bahamas to that in Belize?
Give a very brief answer. 0.48. What is the ratio of the Taxes (in $) of Taxes on revenue in Bahamas to that in Benin?
Offer a terse response. 0. What is the ratio of the Taxes (in $) in Taxes on exports in Bahamas to that in Benin?
Give a very brief answer. 14.67. What is the ratio of the Taxes (in $) in Taxes on goods and services in Bahamas to that in Benin?
Provide a succinct answer. 0. What is the ratio of the Taxes (in $) in Taxes on income in Bahamas to that in Benin?
Offer a terse response. 25.8. What is the ratio of the Taxes (in $) in Taxes on revenue in Bangladesh to that in Belarus?
Ensure brevity in your answer.  0.07. What is the ratio of the Taxes (in $) in Taxes on goods and services in Bangladesh to that in Belarus?
Provide a succinct answer. 0.04. What is the ratio of the Taxes (in $) of Taxes on income in Bangladesh to that in Belarus?
Provide a short and direct response. 11.31. What is the ratio of the Taxes (in $) in Taxes on revenue in Bangladesh to that in Belgium?
Provide a short and direct response. 2.75. What is the ratio of the Taxes (in $) in Taxes on exports in Bangladesh to that in Belgium?
Offer a terse response. 0. What is the ratio of the Taxes (in $) in Taxes on goods and services in Bangladesh to that in Belgium?
Your answer should be compact. 2.57. What is the ratio of the Taxes (in $) of Taxes on income in Bangladesh to that in Belgium?
Offer a terse response. 6087. What is the ratio of the Taxes (in $) in Taxes on revenue in Bangladesh to that in Belize?
Ensure brevity in your answer.  590.62. What is the ratio of the Taxes (in $) in Taxes on exports in Bangladesh to that in Belize?
Your answer should be very brief. 0. What is the ratio of the Taxes (in $) of Taxes on goods and services in Bangladesh to that in Belize?
Ensure brevity in your answer.  616.68. What is the ratio of the Taxes (in $) in Taxes on income in Bangladesh to that in Belize?
Ensure brevity in your answer.  7.29. What is the ratio of the Taxes (in $) in Taxes on revenue in Bangladesh to that in Benin?
Offer a terse response. 0.72. What is the ratio of the Taxes (in $) in Taxes on exports in Bangladesh to that in Benin?
Keep it short and to the point. 0.02. What is the ratio of the Taxes (in $) in Taxes on goods and services in Bangladesh to that in Benin?
Make the answer very short. 0.59. What is the ratio of the Taxes (in $) in Taxes on income in Bangladesh to that in Benin?
Offer a terse response. 393.21. What is the ratio of the Taxes (in $) of Taxes on revenue in Belarus to that in Belgium?
Your answer should be very brief. 38.65. What is the ratio of the Taxes (in $) of Taxes on exports in Belarus to that in Belgium?
Your response must be concise. 6.35. What is the ratio of the Taxes (in $) in Taxes on goods and services in Belarus to that in Belgium?
Offer a terse response. 68.73. What is the ratio of the Taxes (in $) of Taxes on income in Belarus to that in Belgium?
Make the answer very short. 538.22. What is the ratio of the Taxes (in $) in Taxes on revenue in Belarus to that in Belize?
Your answer should be very brief. 8296.5. What is the ratio of the Taxes (in $) of Taxes on exports in Belarus to that in Belize?
Your answer should be very brief. 21.79. What is the ratio of the Taxes (in $) of Taxes on goods and services in Belarus to that in Belize?
Your answer should be very brief. 1.65e+04. What is the ratio of the Taxes (in $) in Taxes on income in Belarus to that in Belize?
Keep it short and to the point. 0.64. What is the ratio of the Taxes (in $) of Taxes on revenue in Belarus to that in Benin?
Your answer should be compact. 10.06. What is the ratio of the Taxes (in $) of Taxes on exports in Belarus to that in Benin?
Make the answer very short. 726.17. What is the ratio of the Taxes (in $) in Taxes on goods and services in Belarus to that in Benin?
Provide a short and direct response. 15.67. What is the ratio of the Taxes (in $) in Taxes on income in Belarus to that in Benin?
Provide a succinct answer. 34.77. What is the ratio of the Taxes (in $) in Taxes on revenue in Belgium to that in Belize?
Make the answer very short. 214.65. What is the ratio of the Taxes (in $) in Taxes on exports in Belgium to that in Belize?
Provide a short and direct response. 3.43. What is the ratio of the Taxes (in $) in Taxes on goods and services in Belgium to that in Belize?
Offer a very short reply. 240.24. What is the ratio of the Taxes (in $) in Taxes on income in Belgium to that in Belize?
Offer a very short reply. 0. What is the ratio of the Taxes (in $) in Taxes on revenue in Belgium to that in Benin?
Give a very brief answer. 0.26. What is the ratio of the Taxes (in $) of Taxes on exports in Belgium to that in Benin?
Provide a short and direct response. 114.44. What is the ratio of the Taxes (in $) in Taxes on goods and services in Belgium to that in Benin?
Your answer should be compact. 0.23. What is the ratio of the Taxes (in $) of Taxes on income in Belgium to that in Benin?
Make the answer very short. 0.06. What is the ratio of the Taxes (in $) of Taxes on revenue in Belize to that in Benin?
Keep it short and to the point. 0. What is the ratio of the Taxes (in $) in Taxes on exports in Belize to that in Benin?
Keep it short and to the point. 33.33. What is the ratio of the Taxes (in $) of Taxes on goods and services in Belize to that in Benin?
Keep it short and to the point. 0. What is the ratio of the Taxes (in $) in Taxes on income in Belize to that in Benin?
Ensure brevity in your answer.  53.92. What is the difference between the highest and the second highest Taxes (in $) in Taxes on revenue?
Keep it short and to the point. 2.44e+12. What is the difference between the highest and the second highest Taxes (in $) of Taxes on exports?
Ensure brevity in your answer.  5.51e+08. What is the difference between the highest and the second highest Taxes (in $) of Taxes on goods and services?
Offer a very short reply. 1.67e+12. What is the difference between the highest and the second highest Taxes (in $) of Taxes on income?
Your response must be concise. 4.04e+11. What is the difference between the highest and the lowest Taxes (in $) of Taxes on revenue?
Your answer should be very brief. 2.71e+12. What is the difference between the highest and the lowest Taxes (in $) of Taxes on exports?
Provide a succinct answer. 6.54e+08. What is the difference between the highest and the lowest Taxes (in $) of Taxes on goods and services?
Ensure brevity in your answer.  1.78e+12. What is the difference between the highest and the lowest Taxes (in $) in Taxes on income?
Provide a short and direct response. 4.69e+11. 